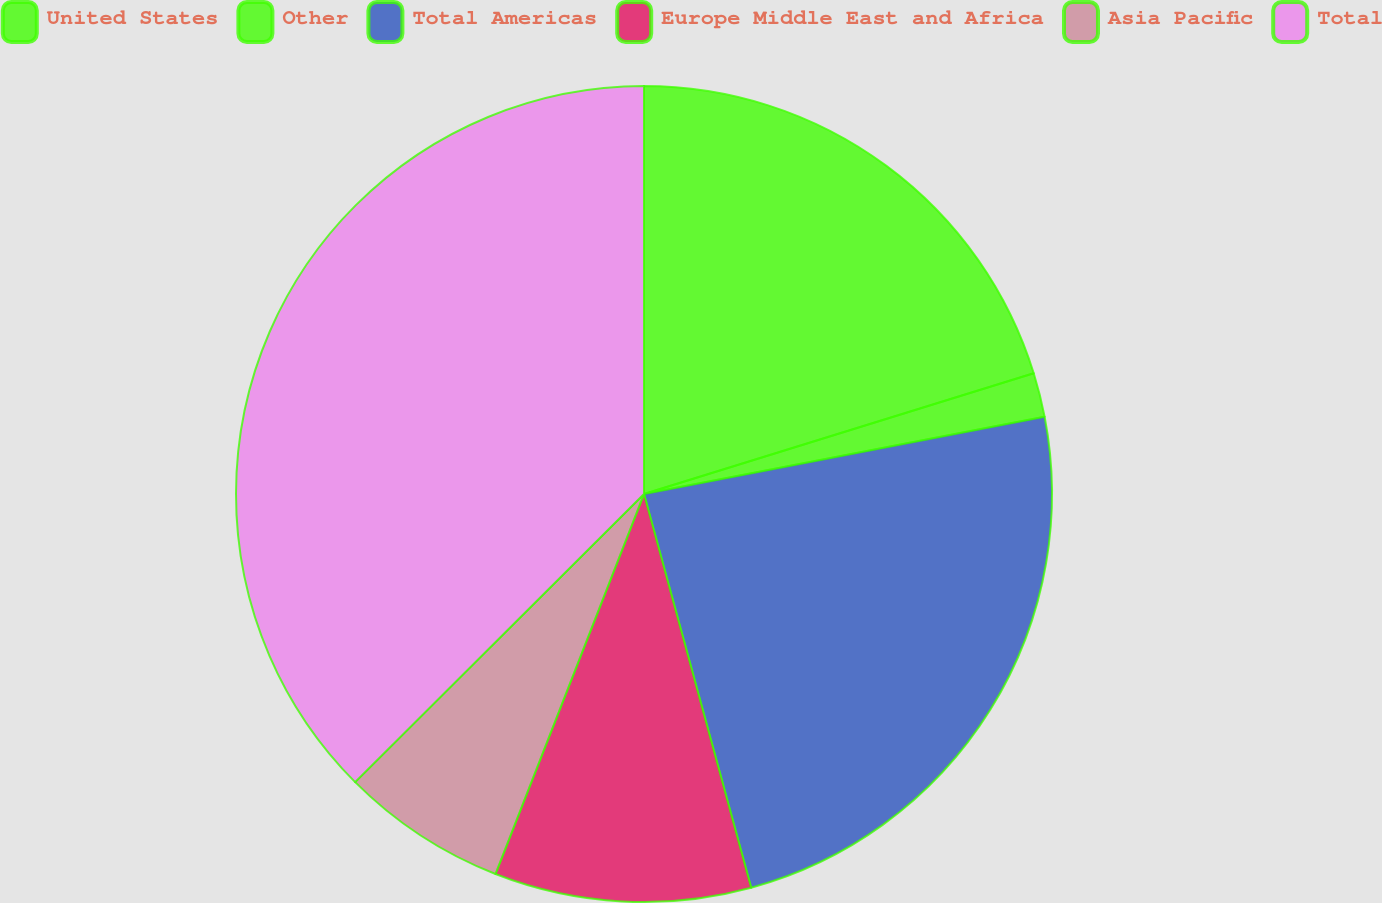Convert chart to OTSL. <chart><loc_0><loc_0><loc_500><loc_500><pie_chart><fcel>United States<fcel>Other<fcel>Total Americas<fcel>Europe Middle East and Africa<fcel>Asia Pacific<fcel>Total<nl><fcel>20.22%<fcel>1.75%<fcel>23.8%<fcel>10.16%<fcel>6.59%<fcel>37.48%<nl></chart> 